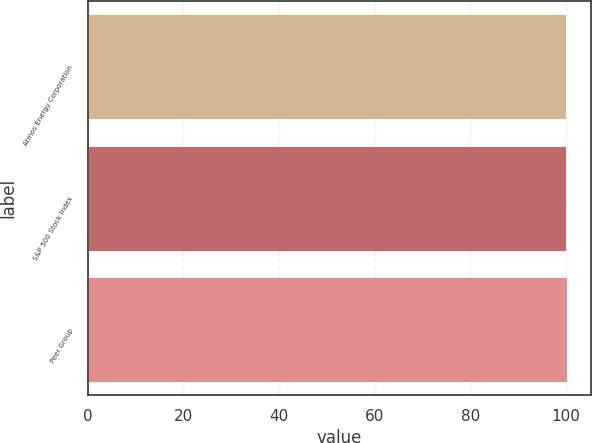<chart> <loc_0><loc_0><loc_500><loc_500><bar_chart><fcel>Atmos Energy Corporation<fcel>S&P 500 Stock Index<fcel>Peer Group<nl><fcel>100<fcel>100.1<fcel>100.2<nl></chart> 